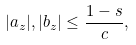<formula> <loc_0><loc_0><loc_500><loc_500>| a _ { z } | , | b _ { z } | \leq \frac { 1 - s } { c } ,</formula> 